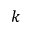<formula> <loc_0><loc_0><loc_500><loc_500>k</formula> 